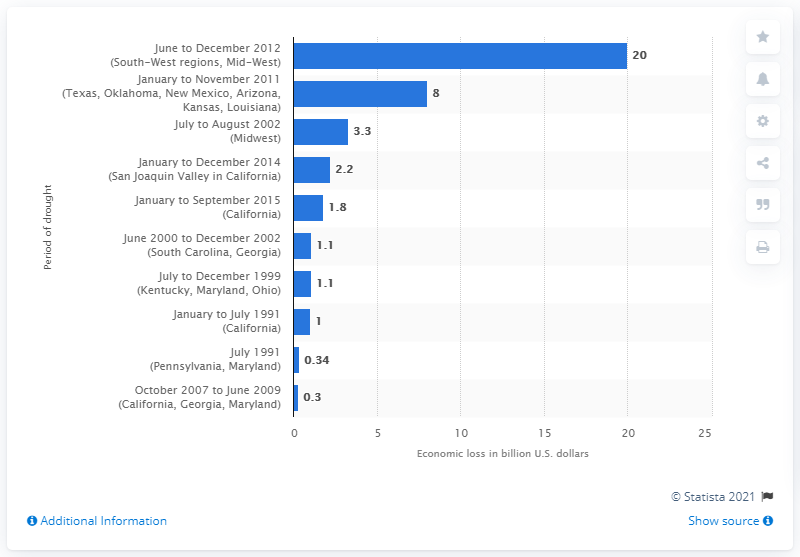Identify some key points in this picture. The drought in 2011 cost the United States approximately $10 billion. 